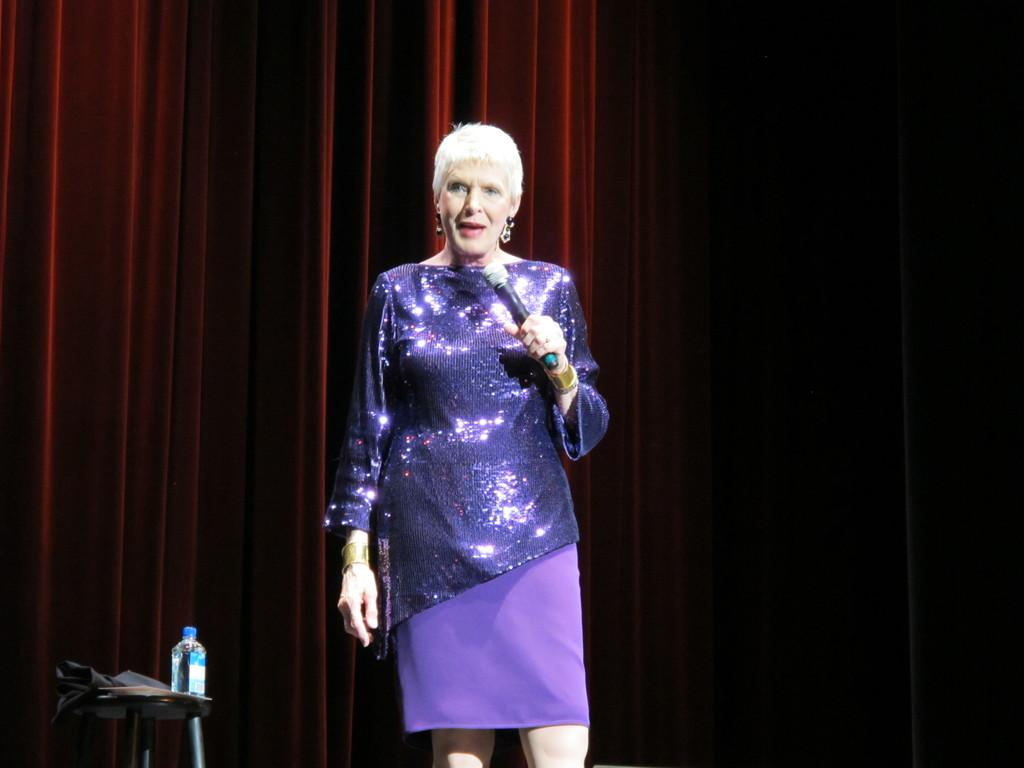What is the woman in the image holding? The woman is holding a microphone. Can you describe the table in the image? There is a table in the bottom left of the image, and it has a cloth on it. What is on the table? There is a bottle on the table. What can be seen in the background of the image? There are curtains in the background of the image. What number is written on the mailbox in the image? There is no mailbox present in the image. What type of rod is used to hold the curtains in the image? There is no rod visible in the image; only the curtains can be seen in the background. 